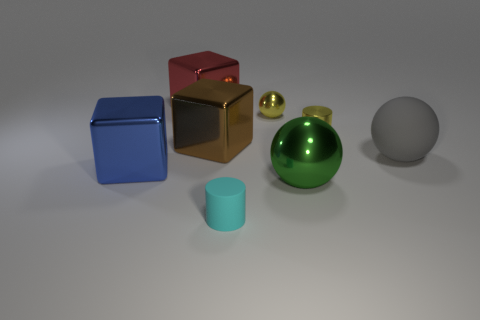The yellow object behind the tiny metallic object that is in front of the tiny yellow metallic object to the left of the big green thing is what shape?
Make the answer very short. Sphere. How many things are metal cylinders or objects that are behind the cyan rubber cylinder?
Provide a short and direct response. 7. How big is the cylinder on the left side of the tiny yellow shiny ball?
Your answer should be very brief. Small. What shape is the metallic thing that is the same color as the tiny shiny cylinder?
Keep it short and to the point. Sphere. Is the material of the large blue object the same as the large ball that is to the left of the large gray rubber ball?
Make the answer very short. Yes. There is a large object on the left side of the big object that is behind the tiny yellow shiny cylinder; what number of big green metallic objects are in front of it?
Ensure brevity in your answer.  1. What number of red objects are tiny balls or large objects?
Your answer should be compact. 1. What shape is the rubber object that is left of the gray matte ball?
Ensure brevity in your answer.  Cylinder. There is a shiny ball that is the same size as the blue thing; what is its color?
Your answer should be very brief. Green. Is the shape of the large blue thing the same as the tiny cyan object left of the large rubber object?
Make the answer very short. No. 